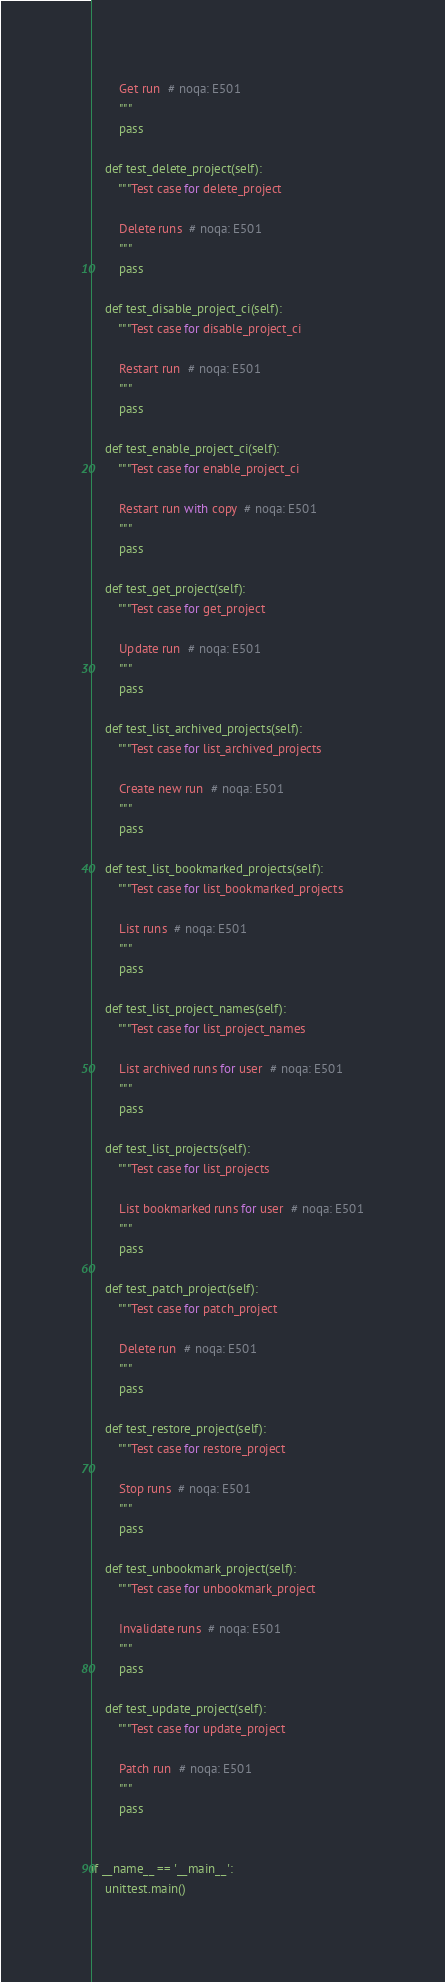<code> <loc_0><loc_0><loc_500><loc_500><_Python_>        Get run  # noqa: E501
        """
        pass

    def test_delete_project(self):
        """Test case for delete_project

        Delete runs  # noqa: E501
        """
        pass

    def test_disable_project_ci(self):
        """Test case for disable_project_ci

        Restart run  # noqa: E501
        """
        pass

    def test_enable_project_ci(self):
        """Test case for enable_project_ci

        Restart run with copy  # noqa: E501
        """
        pass

    def test_get_project(self):
        """Test case for get_project

        Update run  # noqa: E501
        """
        pass

    def test_list_archived_projects(self):
        """Test case for list_archived_projects

        Create new run  # noqa: E501
        """
        pass

    def test_list_bookmarked_projects(self):
        """Test case for list_bookmarked_projects

        List runs  # noqa: E501
        """
        pass

    def test_list_project_names(self):
        """Test case for list_project_names

        List archived runs for user  # noqa: E501
        """
        pass

    def test_list_projects(self):
        """Test case for list_projects

        List bookmarked runs for user  # noqa: E501
        """
        pass

    def test_patch_project(self):
        """Test case for patch_project

        Delete run  # noqa: E501
        """
        pass

    def test_restore_project(self):
        """Test case for restore_project

        Stop runs  # noqa: E501
        """
        pass

    def test_unbookmark_project(self):
        """Test case for unbookmark_project

        Invalidate runs  # noqa: E501
        """
        pass

    def test_update_project(self):
        """Test case for update_project

        Patch run  # noqa: E501
        """
        pass


if __name__ == '__main__':
    unittest.main()
</code> 